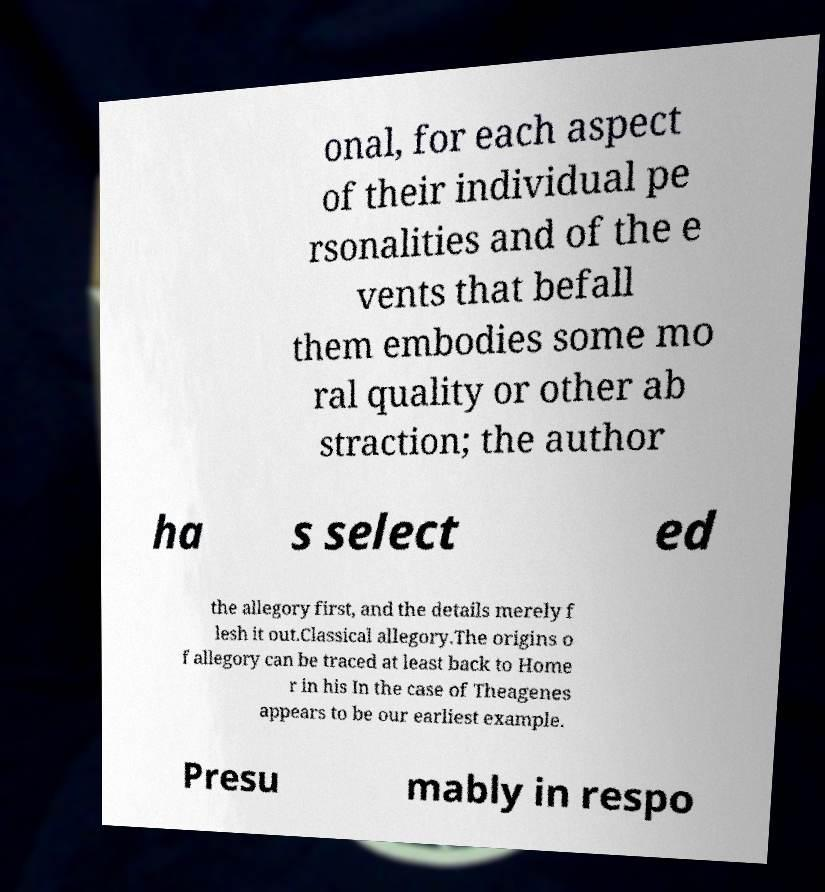Can you accurately transcribe the text from the provided image for me? onal, for each aspect of their individual pe rsonalities and of the e vents that befall them embodies some mo ral quality or other ab straction; the author ha s select ed the allegory first, and the details merely f lesh it out.Classical allegory.The origins o f allegory can be traced at least back to Home r in his In the case of Theagenes appears to be our earliest example. Presu mably in respo 